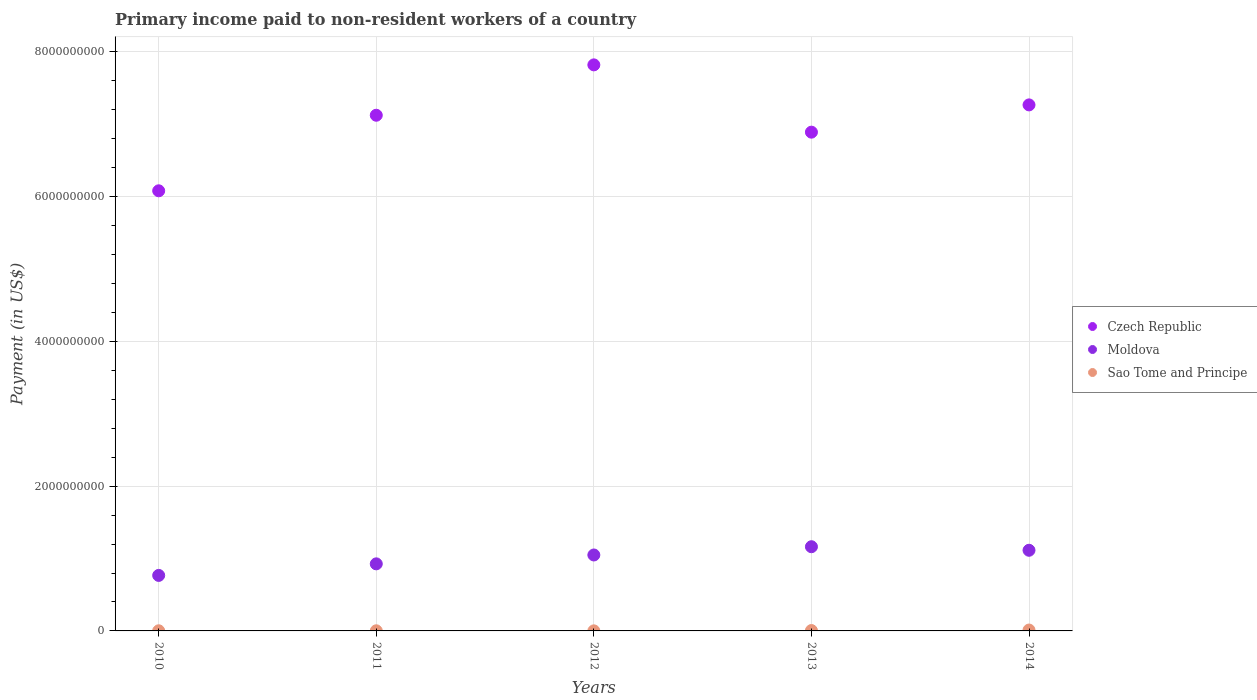How many different coloured dotlines are there?
Provide a short and direct response. 3. What is the amount paid to workers in Moldova in 2010?
Ensure brevity in your answer.  7.67e+08. Across all years, what is the maximum amount paid to workers in Czech Republic?
Make the answer very short. 7.82e+09. Across all years, what is the minimum amount paid to workers in Czech Republic?
Offer a terse response. 6.08e+09. In which year was the amount paid to workers in Moldova maximum?
Ensure brevity in your answer.  2013. In which year was the amount paid to workers in Sao Tome and Principe minimum?
Ensure brevity in your answer.  2012. What is the total amount paid to workers in Moldova in the graph?
Your answer should be very brief. 5.02e+09. What is the difference between the amount paid to workers in Sao Tome and Principe in 2010 and that in 2013?
Give a very brief answer. -3.42e+06. What is the difference between the amount paid to workers in Sao Tome and Principe in 2010 and the amount paid to workers in Moldova in 2012?
Provide a short and direct response. -1.05e+09. What is the average amount paid to workers in Moldova per year?
Ensure brevity in your answer.  1.00e+09. In the year 2012, what is the difference between the amount paid to workers in Moldova and amount paid to workers in Czech Republic?
Provide a short and direct response. -6.77e+09. In how many years, is the amount paid to workers in Sao Tome and Principe greater than 2800000000 US$?
Keep it short and to the point. 0. What is the ratio of the amount paid to workers in Czech Republic in 2012 to that in 2013?
Provide a succinct answer. 1.13. Is the amount paid to workers in Moldova in 2012 less than that in 2014?
Provide a short and direct response. Yes. Is the difference between the amount paid to workers in Moldova in 2010 and 2012 greater than the difference between the amount paid to workers in Czech Republic in 2010 and 2012?
Your answer should be very brief. Yes. What is the difference between the highest and the second highest amount paid to workers in Moldova?
Offer a terse response. 4.90e+07. What is the difference between the highest and the lowest amount paid to workers in Czech Republic?
Your response must be concise. 1.74e+09. Is the sum of the amount paid to workers in Moldova in 2010 and 2014 greater than the maximum amount paid to workers in Sao Tome and Principe across all years?
Make the answer very short. Yes. Is it the case that in every year, the sum of the amount paid to workers in Sao Tome and Principe and amount paid to workers in Moldova  is greater than the amount paid to workers in Czech Republic?
Provide a succinct answer. No. Does the amount paid to workers in Sao Tome and Principe monotonically increase over the years?
Provide a succinct answer. No. Is the amount paid to workers in Moldova strictly greater than the amount paid to workers in Sao Tome and Principe over the years?
Offer a terse response. Yes. Are the values on the major ticks of Y-axis written in scientific E-notation?
Make the answer very short. No. Does the graph contain any zero values?
Ensure brevity in your answer.  No. What is the title of the graph?
Offer a terse response. Primary income paid to non-resident workers of a country. What is the label or title of the X-axis?
Your answer should be very brief. Years. What is the label or title of the Y-axis?
Provide a short and direct response. Payment (in US$). What is the Payment (in US$) in Czech Republic in 2010?
Provide a short and direct response. 6.08e+09. What is the Payment (in US$) of Moldova in 2010?
Provide a short and direct response. 7.67e+08. What is the Payment (in US$) in Sao Tome and Principe in 2010?
Your answer should be compact. 1.89e+06. What is the Payment (in US$) in Czech Republic in 2011?
Offer a very short reply. 7.13e+09. What is the Payment (in US$) of Moldova in 2011?
Ensure brevity in your answer.  9.27e+08. What is the Payment (in US$) in Sao Tome and Principe in 2011?
Provide a short and direct response. 1.87e+06. What is the Payment (in US$) in Czech Republic in 2012?
Ensure brevity in your answer.  7.82e+09. What is the Payment (in US$) of Moldova in 2012?
Provide a short and direct response. 1.05e+09. What is the Payment (in US$) of Sao Tome and Principe in 2012?
Provide a short and direct response. 1.02e+06. What is the Payment (in US$) of Czech Republic in 2013?
Your response must be concise. 6.89e+09. What is the Payment (in US$) of Moldova in 2013?
Your answer should be compact. 1.16e+09. What is the Payment (in US$) of Sao Tome and Principe in 2013?
Your answer should be very brief. 5.31e+06. What is the Payment (in US$) in Czech Republic in 2014?
Ensure brevity in your answer.  7.27e+09. What is the Payment (in US$) of Moldova in 2014?
Give a very brief answer. 1.11e+09. What is the Payment (in US$) of Sao Tome and Principe in 2014?
Ensure brevity in your answer.  1.22e+07. Across all years, what is the maximum Payment (in US$) in Czech Republic?
Make the answer very short. 7.82e+09. Across all years, what is the maximum Payment (in US$) in Moldova?
Make the answer very short. 1.16e+09. Across all years, what is the maximum Payment (in US$) of Sao Tome and Principe?
Provide a succinct answer. 1.22e+07. Across all years, what is the minimum Payment (in US$) in Czech Republic?
Offer a terse response. 6.08e+09. Across all years, what is the minimum Payment (in US$) in Moldova?
Your response must be concise. 7.67e+08. Across all years, what is the minimum Payment (in US$) in Sao Tome and Principe?
Your response must be concise. 1.02e+06. What is the total Payment (in US$) of Czech Republic in the graph?
Offer a terse response. 3.52e+1. What is the total Payment (in US$) of Moldova in the graph?
Your response must be concise. 5.02e+09. What is the total Payment (in US$) in Sao Tome and Principe in the graph?
Make the answer very short. 2.23e+07. What is the difference between the Payment (in US$) of Czech Republic in 2010 and that in 2011?
Provide a succinct answer. -1.04e+09. What is the difference between the Payment (in US$) in Moldova in 2010 and that in 2011?
Provide a succinct answer. -1.60e+08. What is the difference between the Payment (in US$) in Sao Tome and Principe in 2010 and that in 2011?
Keep it short and to the point. 2.78e+04. What is the difference between the Payment (in US$) in Czech Republic in 2010 and that in 2012?
Provide a succinct answer. -1.74e+09. What is the difference between the Payment (in US$) of Moldova in 2010 and that in 2012?
Provide a short and direct response. -2.82e+08. What is the difference between the Payment (in US$) in Sao Tome and Principe in 2010 and that in 2012?
Your answer should be very brief. 8.74e+05. What is the difference between the Payment (in US$) of Czech Republic in 2010 and that in 2013?
Offer a terse response. -8.10e+08. What is the difference between the Payment (in US$) in Moldova in 2010 and that in 2013?
Your response must be concise. -3.96e+08. What is the difference between the Payment (in US$) of Sao Tome and Principe in 2010 and that in 2013?
Your answer should be very brief. -3.42e+06. What is the difference between the Payment (in US$) of Czech Republic in 2010 and that in 2014?
Provide a succinct answer. -1.19e+09. What is the difference between the Payment (in US$) in Moldova in 2010 and that in 2014?
Give a very brief answer. -3.47e+08. What is the difference between the Payment (in US$) in Sao Tome and Principe in 2010 and that in 2014?
Give a very brief answer. -1.03e+07. What is the difference between the Payment (in US$) in Czech Republic in 2011 and that in 2012?
Offer a terse response. -6.96e+08. What is the difference between the Payment (in US$) of Moldova in 2011 and that in 2012?
Ensure brevity in your answer.  -1.23e+08. What is the difference between the Payment (in US$) of Sao Tome and Principe in 2011 and that in 2012?
Your response must be concise. 8.46e+05. What is the difference between the Payment (in US$) of Czech Republic in 2011 and that in 2013?
Your answer should be very brief. 2.34e+08. What is the difference between the Payment (in US$) of Moldova in 2011 and that in 2013?
Your answer should be very brief. -2.37e+08. What is the difference between the Payment (in US$) of Sao Tome and Principe in 2011 and that in 2013?
Make the answer very short. -3.45e+06. What is the difference between the Payment (in US$) of Czech Republic in 2011 and that in 2014?
Your response must be concise. -1.43e+08. What is the difference between the Payment (in US$) of Moldova in 2011 and that in 2014?
Provide a short and direct response. -1.88e+08. What is the difference between the Payment (in US$) of Sao Tome and Principe in 2011 and that in 2014?
Your response must be concise. -1.03e+07. What is the difference between the Payment (in US$) in Czech Republic in 2012 and that in 2013?
Keep it short and to the point. 9.30e+08. What is the difference between the Payment (in US$) in Moldova in 2012 and that in 2013?
Offer a terse response. -1.14e+08. What is the difference between the Payment (in US$) of Sao Tome and Principe in 2012 and that in 2013?
Your response must be concise. -4.29e+06. What is the difference between the Payment (in US$) of Czech Republic in 2012 and that in 2014?
Provide a short and direct response. 5.53e+08. What is the difference between the Payment (in US$) in Moldova in 2012 and that in 2014?
Provide a succinct answer. -6.50e+07. What is the difference between the Payment (in US$) in Sao Tome and Principe in 2012 and that in 2014?
Provide a succinct answer. -1.11e+07. What is the difference between the Payment (in US$) in Czech Republic in 2013 and that in 2014?
Your answer should be compact. -3.77e+08. What is the difference between the Payment (in US$) of Moldova in 2013 and that in 2014?
Provide a short and direct response. 4.90e+07. What is the difference between the Payment (in US$) of Sao Tome and Principe in 2013 and that in 2014?
Keep it short and to the point. -6.84e+06. What is the difference between the Payment (in US$) in Czech Republic in 2010 and the Payment (in US$) in Moldova in 2011?
Provide a short and direct response. 5.15e+09. What is the difference between the Payment (in US$) in Czech Republic in 2010 and the Payment (in US$) in Sao Tome and Principe in 2011?
Your answer should be compact. 6.08e+09. What is the difference between the Payment (in US$) in Moldova in 2010 and the Payment (in US$) in Sao Tome and Principe in 2011?
Provide a short and direct response. 7.65e+08. What is the difference between the Payment (in US$) of Czech Republic in 2010 and the Payment (in US$) of Moldova in 2012?
Offer a very short reply. 5.03e+09. What is the difference between the Payment (in US$) of Czech Republic in 2010 and the Payment (in US$) of Sao Tome and Principe in 2012?
Your answer should be very brief. 6.08e+09. What is the difference between the Payment (in US$) of Moldova in 2010 and the Payment (in US$) of Sao Tome and Principe in 2012?
Offer a very short reply. 7.66e+08. What is the difference between the Payment (in US$) of Czech Republic in 2010 and the Payment (in US$) of Moldova in 2013?
Your answer should be compact. 4.92e+09. What is the difference between the Payment (in US$) in Czech Republic in 2010 and the Payment (in US$) in Sao Tome and Principe in 2013?
Give a very brief answer. 6.08e+09. What is the difference between the Payment (in US$) of Moldova in 2010 and the Payment (in US$) of Sao Tome and Principe in 2013?
Provide a short and direct response. 7.62e+08. What is the difference between the Payment (in US$) of Czech Republic in 2010 and the Payment (in US$) of Moldova in 2014?
Offer a very short reply. 4.97e+09. What is the difference between the Payment (in US$) in Czech Republic in 2010 and the Payment (in US$) in Sao Tome and Principe in 2014?
Your response must be concise. 6.07e+09. What is the difference between the Payment (in US$) in Moldova in 2010 and the Payment (in US$) in Sao Tome and Principe in 2014?
Your answer should be compact. 7.55e+08. What is the difference between the Payment (in US$) in Czech Republic in 2011 and the Payment (in US$) in Moldova in 2012?
Your response must be concise. 6.08e+09. What is the difference between the Payment (in US$) of Czech Republic in 2011 and the Payment (in US$) of Sao Tome and Principe in 2012?
Your response must be concise. 7.12e+09. What is the difference between the Payment (in US$) of Moldova in 2011 and the Payment (in US$) of Sao Tome and Principe in 2012?
Make the answer very short. 9.26e+08. What is the difference between the Payment (in US$) in Czech Republic in 2011 and the Payment (in US$) in Moldova in 2013?
Your response must be concise. 5.96e+09. What is the difference between the Payment (in US$) in Czech Republic in 2011 and the Payment (in US$) in Sao Tome and Principe in 2013?
Provide a short and direct response. 7.12e+09. What is the difference between the Payment (in US$) in Moldova in 2011 and the Payment (in US$) in Sao Tome and Principe in 2013?
Provide a succinct answer. 9.21e+08. What is the difference between the Payment (in US$) in Czech Republic in 2011 and the Payment (in US$) in Moldova in 2014?
Ensure brevity in your answer.  6.01e+09. What is the difference between the Payment (in US$) in Czech Republic in 2011 and the Payment (in US$) in Sao Tome and Principe in 2014?
Your answer should be very brief. 7.11e+09. What is the difference between the Payment (in US$) of Moldova in 2011 and the Payment (in US$) of Sao Tome and Principe in 2014?
Your answer should be very brief. 9.15e+08. What is the difference between the Payment (in US$) in Czech Republic in 2012 and the Payment (in US$) in Moldova in 2013?
Offer a very short reply. 6.66e+09. What is the difference between the Payment (in US$) of Czech Republic in 2012 and the Payment (in US$) of Sao Tome and Principe in 2013?
Give a very brief answer. 7.82e+09. What is the difference between the Payment (in US$) in Moldova in 2012 and the Payment (in US$) in Sao Tome and Principe in 2013?
Keep it short and to the point. 1.04e+09. What is the difference between the Payment (in US$) of Czech Republic in 2012 and the Payment (in US$) of Moldova in 2014?
Keep it short and to the point. 6.71e+09. What is the difference between the Payment (in US$) in Czech Republic in 2012 and the Payment (in US$) in Sao Tome and Principe in 2014?
Give a very brief answer. 7.81e+09. What is the difference between the Payment (in US$) of Moldova in 2012 and the Payment (in US$) of Sao Tome and Principe in 2014?
Provide a succinct answer. 1.04e+09. What is the difference between the Payment (in US$) in Czech Republic in 2013 and the Payment (in US$) in Moldova in 2014?
Your answer should be compact. 5.78e+09. What is the difference between the Payment (in US$) of Czech Republic in 2013 and the Payment (in US$) of Sao Tome and Principe in 2014?
Your response must be concise. 6.88e+09. What is the difference between the Payment (in US$) in Moldova in 2013 and the Payment (in US$) in Sao Tome and Principe in 2014?
Offer a terse response. 1.15e+09. What is the average Payment (in US$) in Czech Republic per year?
Keep it short and to the point. 7.04e+09. What is the average Payment (in US$) in Moldova per year?
Keep it short and to the point. 1.00e+09. What is the average Payment (in US$) of Sao Tome and Principe per year?
Keep it short and to the point. 4.45e+06. In the year 2010, what is the difference between the Payment (in US$) of Czech Republic and Payment (in US$) of Moldova?
Your answer should be very brief. 5.31e+09. In the year 2010, what is the difference between the Payment (in US$) of Czech Republic and Payment (in US$) of Sao Tome and Principe?
Offer a terse response. 6.08e+09. In the year 2010, what is the difference between the Payment (in US$) in Moldova and Payment (in US$) in Sao Tome and Principe?
Provide a short and direct response. 7.65e+08. In the year 2011, what is the difference between the Payment (in US$) in Czech Republic and Payment (in US$) in Moldova?
Offer a very short reply. 6.20e+09. In the year 2011, what is the difference between the Payment (in US$) of Czech Republic and Payment (in US$) of Sao Tome and Principe?
Offer a very short reply. 7.12e+09. In the year 2011, what is the difference between the Payment (in US$) of Moldova and Payment (in US$) of Sao Tome and Principe?
Offer a terse response. 9.25e+08. In the year 2012, what is the difference between the Payment (in US$) in Czech Republic and Payment (in US$) in Moldova?
Offer a terse response. 6.77e+09. In the year 2012, what is the difference between the Payment (in US$) of Czech Republic and Payment (in US$) of Sao Tome and Principe?
Ensure brevity in your answer.  7.82e+09. In the year 2012, what is the difference between the Payment (in US$) of Moldova and Payment (in US$) of Sao Tome and Principe?
Keep it short and to the point. 1.05e+09. In the year 2013, what is the difference between the Payment (in US$) of Czech Republic and Payment (in US$) of Moldova?
Provide a succinct answer. 5.73e+09. In the year 2013, what is the difference between the Payment (in US$) in Czech Republic and Payment (in US$) in Sao Tome and Principe?
Offer a very short reply. 6.89e+09. In the year 2013, what is the difference between the Payment (in US$) in Moldova and Payment (in US$) in Sao Tome and Principe?
Provide a short and direct response. 1.16e+09. In the year 2014, what is the difference between the Payment (in US$) of Czech Republic and Payment (in US$) of Moldova?
Make the answer very short. 6.15e+09. In the year 2014, what is the difference between the Payment (in US$) of Czech Republic and Payment (in US$) of Sao Tome and Principe?
Keep it short and to the point. 7.26e+09. In the year 2014, what is the difference between the Payment (in US$) of Moldova and Payment (in US$) of Sao Tome and Principe?
Offer a very short reply. 1.10e+09. What is the ratio of the Payment (in US$) in Czech Republic in 2010 to that in 2011?
Provide a short and direct response. 0.85. What is the ratio of the Payment (in US$) of Moldova in 2010 to that in 2011?
Provide a short and direct response. 0.83. What is the ratio of the Payment (in US$) in Sao Tome and Principe in 2010 to that in 2011?
Provide a short and direct response. 1.01. What is the ratio of the Payment (in US$) in Czech Republic in 2010 to that in 2012?
Your answer should be compact. 0.78. What is the ratio of the Payment (in US$) in Moldova in 2010 to that in 2012?
Ensure brevity in your answer.  0.73. What is the ratio of the Payment (in US$) of Sao Tome and Principe in 2010 to that in 2012?
Make the answer very short. 1.86. What is the ratio of the Payment (in US$) of Czech Republic in 2010 to that in 2013?
Provide a short and direct response. 0.88. What is the ratio of the Payment (in US$) of Moldova in 2010 to that in 2013?
Give a very brief answer. 0.66. What is the ratio of the Payment (in US$) in Sao Tome and Principe in 2010 to that in 2013?
Provide a short and direct response. 0.36. What is the ratio of the Payment (in US$) in Czech Republic in 2010 to that in 2014?
Provide a short and direct response. 0.84. What is the ratio of the Payment (in US$) of Moldova in 2010 to that in 2014?
Provide a succinct answer. 0.69. What is the ratio of the Payment (in US$) in Sao Tome and Principe in 2010 to that in 2014?
Offer a terse response. 0.16. What is the ratio of the Payment (in US$) in Czech Republic in 2011 to that in 2012?
Your response must be concise. 0.91. What is the ratio of the Payment (in US$) in Moldova in 2011 to that in 2012?
Provide a short and direct response. 0.88. What is the ratio of the Payment (in US$) in Sao Tome and Principe in 2011 to that in 2012?
Give a very brief answer. 1.83. What is the ratio of the Payment (in US$) in Czech Republic in 2011 to that in 2013?
Provide a short and direct response. 1.03. What is the ratio of the Payment (in US$) in Moldova in 2011 to that in 2013?
Your answer should be compact. 0.8. What is the ratio of the Payment (in US$) of Sao Tome and Principe in 2011 to that in 2013?
Your response must be concise. 0.35. What is the ratio of the Payment (in US$) of Czech Republic in 2011 to that in 2014?
Offer a terse response. 0.98. What is the ratio of the Payment (in US$) of Moldova in 2011 to that in 2014?
Your answer should be very brief. 0.83. What is the ratio of the Payment (in US$) of Sao Tome and Principe in 2011 to that in 2014?
Provide a short and direct response. 0.15. What is the ratio of the Payment (in US$) in Czech Republic in 2012 to that in 2013?
Provide a short and direct response. 1.13. What is the ratio of the Payment (in US$) of Moldova in 2012 to that in 2013?
Keep it short and to the point. 0.9. What is the ratio of the Payment (in US$) of Sao Tome and Principe in 2012 to that in 2013?
Make the answer very short. 0.19. What is the ratio of the Payment (in US$) of Czech Republic in 2012 to that in 2014?
Give a very brief answer. 1.08. What is the ratio of the Payment (in US$) in Moldova in 2012 to that in 2014?
Your response must be concise. 0.94. What is the ratio of the Payment (in US$) of Sao Tome and Principe in 2012 to that in 2014?
Offer a terse response. 0.08. What is the ratio of the Payment (in US$) of Czech Republic in 2013 to that in 2014?
Offer a terse response. 0.95. What is the ratio of the Payment (in US$) of Moldova in 2013 to that in 2014?
Make the answer very short. 1.04. What is the ratio of the Payment (in US$) of Sao Tome and Principe in 2013 to that in 2014?
Make the answer very short. 0.44. What is the difference between the highest and the second highest Payment (in US$) of Czech Republic?
Give a very brief answer. 5.53e+08. What is the difference between the highest and the second highest Payment (in US$) in Moldova?
Keep it short and to the point. 4.90e+07. What is the difference between the highest and the second highest Payment (in US$) in Sao Tome and Principe?
Give a very brief answer. 6.84e+06. What is the difference between the highest and the lowest Payment (in US$) in Czech Republic?
Make the answer very short. 1.74e+09. What is the difference between the highest and the lowest Payment (in US$) of Moldova?
Keep it short and to the point. 3.96e+08. What is the difference between the highest and the lowest Payment (in US$) in Sao Tome and Principe?
Your answer should be compact. 1.11e+07. 